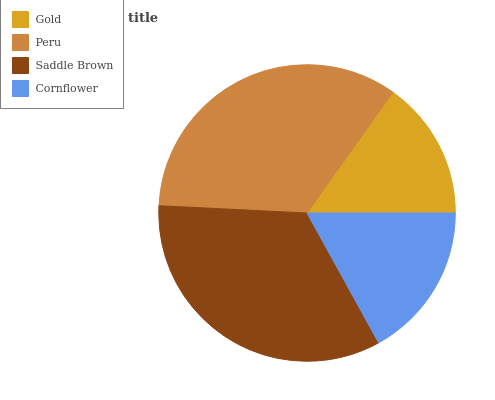Is Gold the minimum?
Answer yes or no. Yes. Is Peru the maximum?
Answer yes or no. Yes. Is Saddle Brown the minimum?
Answer yes or no. No. Is Saddle Brown the maximum?
Answer yes or no. No. Is Peru greater than Saddle Brown?
Answer yes or no. Yes. Is Saddle Brown less than Peru?
Answer yes or no. Yes. Is Saddle Brown greater than Peru?
Answer yes or no. No. Is Peru less than Saddle Brown?
Answer yes or no. No. Is Saddle Brown the high median?
Answer yes or no. Yes. Is Cornflower the low median?
Answer yes or no. Yes. Is Gold the high median?
Answer yes or no. No. Is Gold the low median?
Answer yes or no. No. 